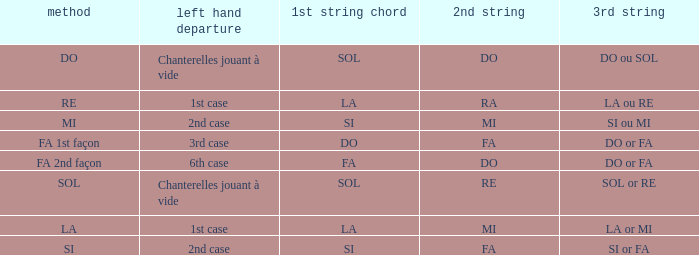What is the mode of the Depart de la main gauche of 1st case and a la or mi 3rd string? LA. 